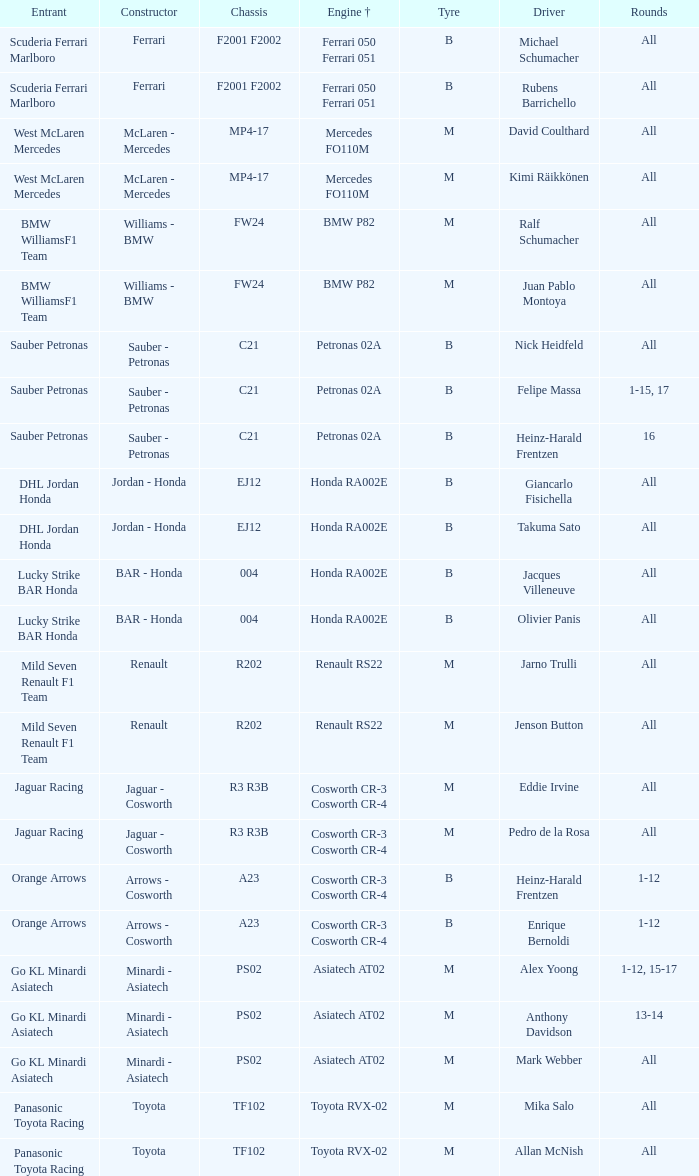Who is the entrant when the engine is bmw p82? BMW WilliamsF1 Team, BMW WilliamsF1 Team. 